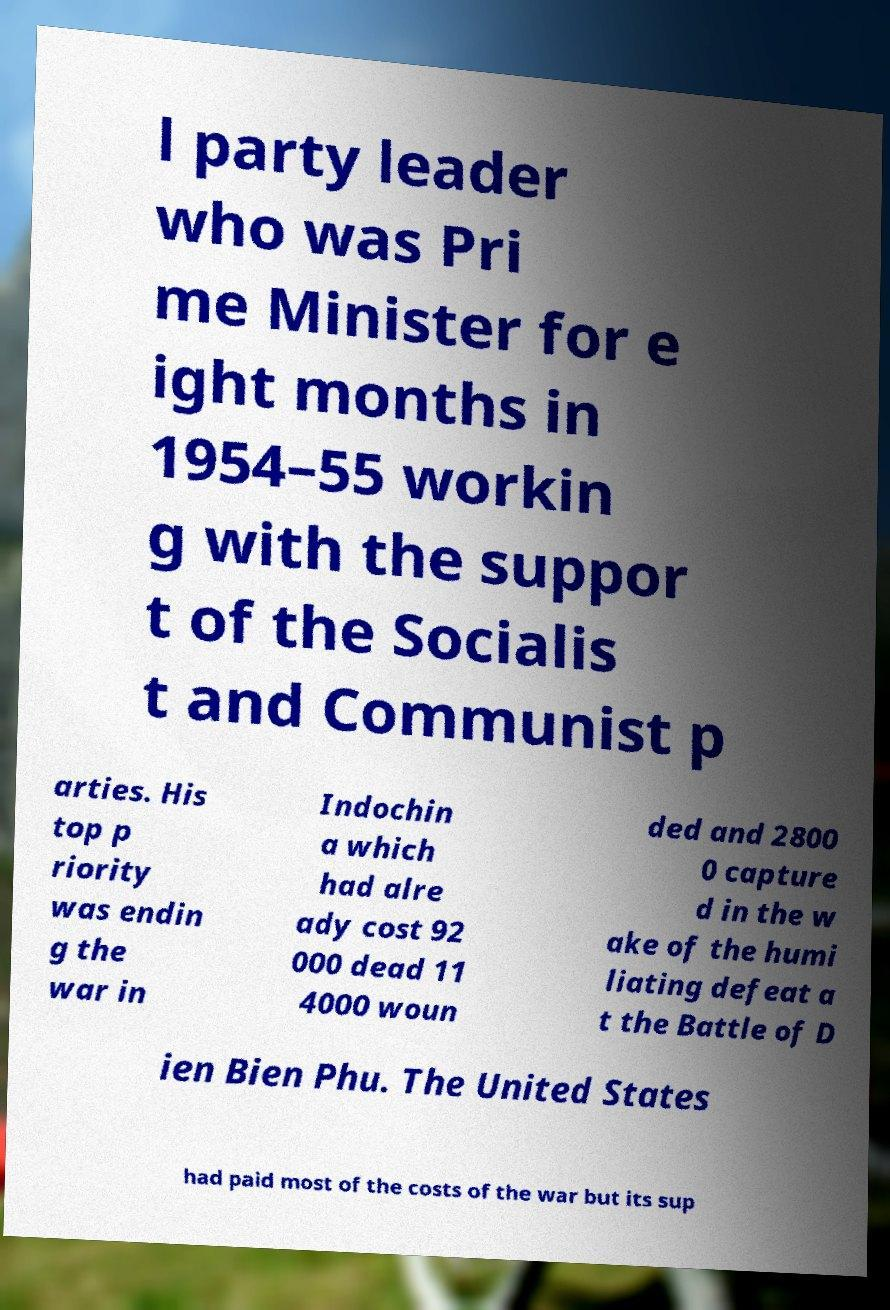Please read and relay the text visible in this image. What does it say? l party leader who was Pri me Minister for e ight months in 1954–55 workin g with the suppor t of the Socialis t and Communist p arties. His top p riority was endin g the war in Indochin a which had alre ady cost 92 000 dead 11 4000 woun ded and 2800 0 capture d in the w ake of the humi liating defeat a t the Battle of D ien Bien Phu. The United States had paid most of the costs of the war but its sup 